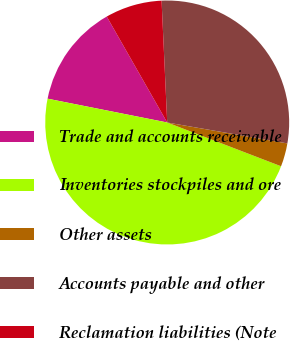Convert chart to OTSL. <chart><loc_0><loc_0><loc_500><loc_500><pie_chart><fcel>Trade and accounts receivable<fcel>Inventories stockpiles and ore<fcel>Other assets<fcel>Accounts payable and other<fcel>Reclamation liabilities (Note<nl><fcel>13.62%<fcel>47.29%<fcel>3.1%<fcel>28.48%<fcel>7.52%<nl></chart> 